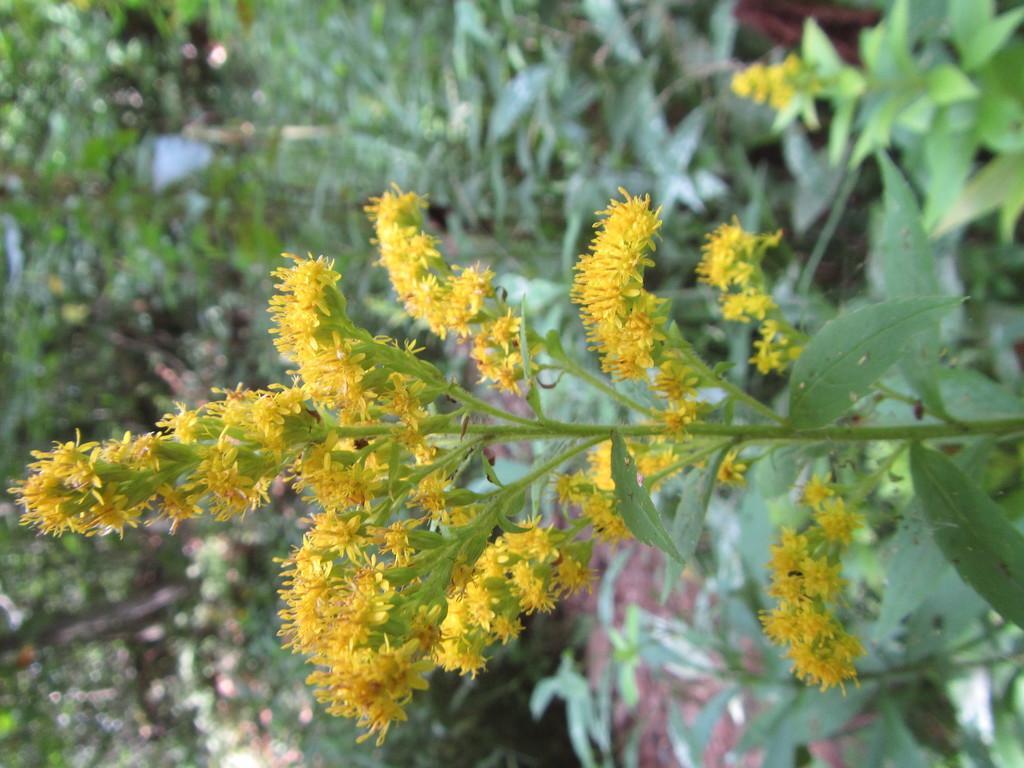How would you summarize this image in a sentence or two? In this picture there is giant goldenrod plant in the image and there are other plants in the background area of the image. 